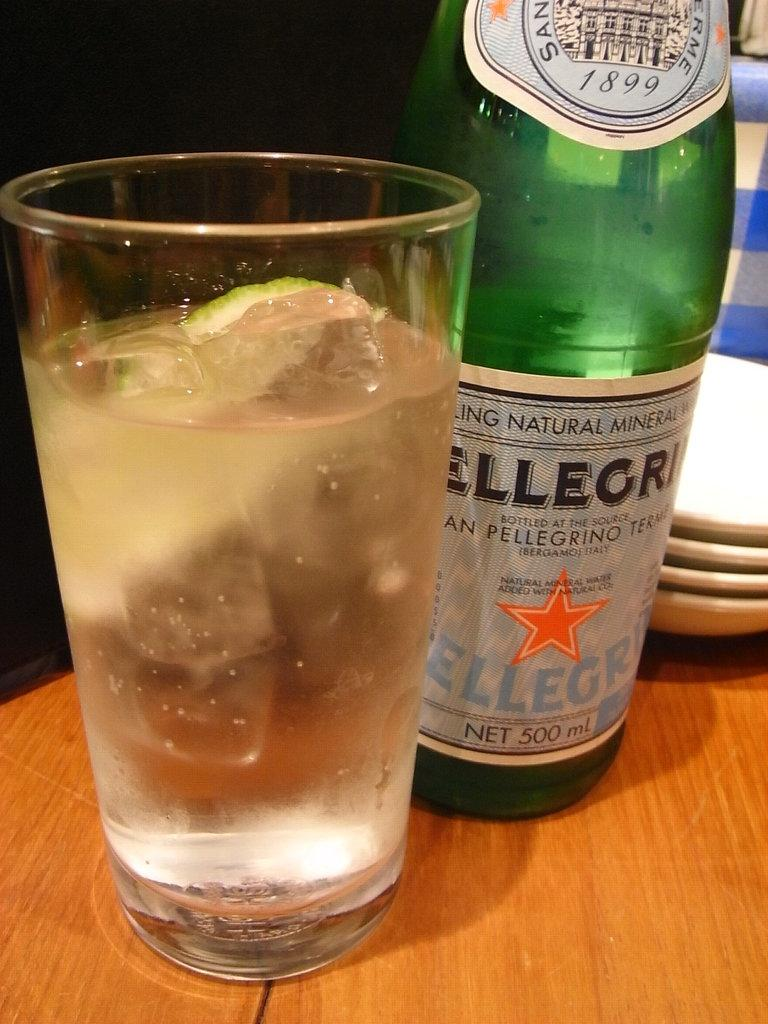<image>
Describe the image concisely. A bottle of Pellegri next to a full glass. 